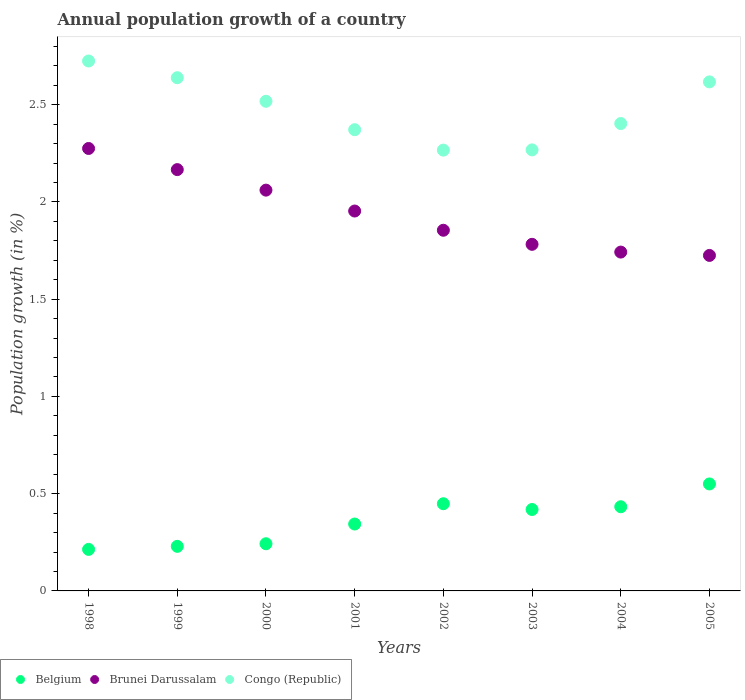What is the annual population growth in Congo (Republic) in 2002?
Ensure brevity in your answer.  2.27. Across all years, what is the maximum annual population growth in Congo (Republic)?
Ensure brevity in your answer.  2.72. Across all years, what is the minimum annual population growth in Brunei Darussalam?
Offer a terse response. 1.72. In which year was the annual population growth in Congo (Republic) minimum?
Give a very brief answer. 2002. What is the total annual population growth in Congo (Republic) in the graph?
Make the answer very short. 19.81. What is the difference between the annual population growth in Belgium in 2003 and that in 2004?
Your answer should be compact. -0.01. What is the difference between the annual population growth in Belgium in 2002 and the annual population growth in Brunei Darussalam in 2000?
Ensure brevity in your answer.  -1.61. What is the average annual population growth in Brunei Darussalam per year?
Keep it short and to the point. 1.94. In the year 1999, what is the difference between the annual population growth in Belgium and annual population growth in Congo (Republic)?
Provide a short and direct response. -2.41. In how many years, is the annual population growth in Belgium greater than 1.2 %?
Give a very brief answer. 0. What is the ratio of the annual population growth in Congo (Republic) in 2002 to that in 2004?
Your response must be concise. 0.94. Is the annual population growth in Belgium in 1998 less than that in 2003?
Offer a terse response. Yes. Is the difference between the annual population growth in Belgium in 2001 and 2004 greater than the difference between the annual population growth in Congo (Republic) in 2001 and 2004?
Provide a succinct answer. No. What is the difference between the highest and the second highest annual population growth in Congo (Republic)?
Your answer should be very brief. 0.09. What is the difference between the highest and the lowest annual population growth in Belgium?
Provide a short and direct response. 0.34. Does the annual population growth in Congo (Republic) monotonically increase over the years?
Your answer should be very brief. No. Is the annual population growth in Belgium strictly less than the annual population growth in Brunei Darussalam over the years?
Keep it short and to the point. Yes. How many dotlines are there?
Provide a succinct answer. 3. How many years are there in the graph?
Offer a terse response. 8. What is the difference between two consecutive major ticks on the Y-axis?
Provide a succinct answer. 0.5. Are the values on the major ticks of Y-axis written in scientific E-notation?
Ensure brevity in your answer.  No. Does the graph contain any zero values?
Make the answer very short. No. How are the legend labels stacked?
Give a very brief answer. Horizontal. What is the title of the graph?
Your response must be concise. Annual population growth of a country. What is the label or title of the Y-axis?
Make the answer very short. Population growth (in %). What is the Population growth (in %) of Belgium in 1998?
Your answer should be very brief. 0.21. What is the Population growth (in %) of Brunei Darussalam in 1998?
Give a very brief answer. 2.27. What is the Population growth (in %) in Congo (Republic) in 1998?
Your answer should be very brief. 2.72. What is the Population growth (in %) of Belgium in 1999?
Your answer should be very brief. 0.23. What is the Population growth (in %) of Brunei Darussalam in 1999?
Give a very brief answer. 2.17. What is the Population growth (in %) of Congo (Republic) in 1999?
Offer a very short reply. 2.64. What is the Population growth (in %) in Belgium in 2000?
Give a very brief answer. 0.24. What is the Population growth (in %) of Brunei Darussalam in 2000?
Make the answer very short. 2.06. What is the Population growth (in %) in Congo (Republic) in 2000?
Give a very brief answer. 2.52. What is the Population growth (in %) in Belgium in 2001?
Your response must be concise. 0.34. What is the Population growth (in %) of Brunei Darussalam in 2001?
Ensure brevity in your answer.  1.95. What is the Population growth (in %) in Congo (Republic) in 2001?
Provide a succinct answer. 2.37. What is the Population growth (in %) in Belgium in 2002?
Offer a very short reply. 0.45. What is the Population growth (in %) in Brunei Darussalam in 2002?
Offer a very short reply. 1.85. What is the Population growth (in %) in Congo (Republic) in 2002?
Offer a terse response. 2.27. What is the Population growth (in %) of Belgium in 2003?
Your answer should be compact. 0.42. What is the Population growth (in %) of Brunei Darussalam in 2003?
Ensure brevity in your answer.  1.78. What is the Population growth (in %) in Congo (Republic) in 2003?
Offer a very short reply. 2.27. What is the Population growth (in %) in Belgium in 2004?
Make the answer very short. 0.43. What is the Population growth (in %) in Brunei Darussalam in 2004?
Offer a terse response. 1.74. What is the Population growth (in %) in Congo (Republic) in 2004?
Provide a succinct answer. 2.4. What is the Population growth (in %) of Belgium in 2005?
Your response must be concise. 0.55. What is the Population growth (in %) in Brunei Darussalam in 2005?
Your answer should be compact. 1.72. What is the Population growth (in %) in Congo (Republic) in 2005?
Your response must be concise. 2.62. Across all years, what is the maximum Population growth (in %) in Belgium?
Keep it short and to the point. 0.55. Across all years, what is the maximum Population growth (in %) in Brunei Darussalam?
Keep it short and to the point. 2.27. Across all years, what is the maximum Population growth (in %) of Congo (Republic)?
Offer a terse response. 2.72. Across all years, what is the minimum Population growth (in %) in Belgium?
Offer a very short reply. 0.21. Across all years, what is the minimum Population growth (in %) in Brunei Darussalam?
Your response must be concise. 1.72. Across all years, what is the minimum Population growth (in %) in Congo (Republic)?
Provide a short and direct response. 2.27. What is the total Population growth (in %) of Belgium in the graph?
Provide a succinct answer. 2.88. What is the total Population growth (in %) in Brunei Darussalam in the graph?
Ensure brevity in your answer.  15.56. What is the total Population growth (in %) of Congo (Republic) in the graph?
Ensure brevity in your answer.  19.81. What is the difference between the Population growth (in %) of Belgium in 1998 and that in 1999?
Keep it short and to the point. -0.02. What is the difference between the Population growth (in %) of Brunei Darussalam in 1998 and that in 1999?
Ensure brevity in your answer.  0.11. What is the difference between the Population growth (in %) in Congo (Republic) in 1998 and that in 1999?
Provide a short and direct response. 0.09. What is the difference between the Population growth (in %) in Belgium in 1998 and that in 2000?
Your answer should be compact. -0.03. What is the difference between the Population growth (in %) in Brunei Darussalam in 1998 and that in 2000?
Make the answer very short. 0.21. What is the difference between the Population growth (in %) of Congo (Republic) in 1998 and that in 2000?
Give a very brief answer. 0.21. What is the difference between the Population growth (in %) in Belgium in 1998 and that in 2001?
Give a very brief answer. -0.13. What is the difference between the Population growth (in %) of Brunei Darussalam in 1998 and that in 2001?
Provide a short and direct response. 0.32. What is the difference between the Population growth (in %) in Congo (Republic) in 1998 and that in 2001?
Make the answer very short. 0.35. What is the difference between the Population growth (in %) in Belgium in 1998 and that in 2002?
Offer a terse response. -0.23. What is the difference between the Population growth (in %) in Brunei Darussalam in 1998 and that in 2002?
Your answer should be very brief. 0.42. What is the difference between the Population growth (in %) in Congo (Republic) in 1998 and that in 2002?
Offer a very short reply. 0.46. What is the difference between the Population growth (in %) in Belgium in 1998 and that in 2003?
Provide a succinct answer. -0.21. What is the difference between the Population growth (in %) in Brunei Darussalam in 1998 and that in 2003?
Ensure brevity in your answer.  0.49. What is the difference between the Population growth (in %) in Congo (Republic) in 1998 and that in 2003?
Offer a terse response. 0.46. What is the difference between the Population growth (in %) of Belgium in 1998 and that in 2004?
Your answer should be compact. -0.22. What is the difference between the Population growth (in %) of Brunei Darussalam in 1998 and that in 2004?
Your answer should be compact. 0.53. What is the difference between the Population growth (in %) of Congo (Republic) in 1998 and that in 2004?
Your response must be concise. 0.32. What is the difference between the Population growth (in %) in Belgium in 1998 and that in 2005?
Your answer should be very brief. -0.34. What is the difference between the Population growth (in %) of Brunei Darussalam in 1998 and that in 2005?
Give a very brief answer. 0.55. What is the difference between the Population growth (in %) in Congo (Republic) in 1998 and that in 2005?
Provide a succinct answer. 0.11. What is the difference between the Population growth (in %) of Belgium in 1999 and that in 2000?
Offer a very short reply. -0.01. What is the difference between the Population growth (in %) in Brunei Darussalam in 1999 and that in 2000?
Offer a very short reply. 0.11. What is the difference between the Population growth (in %) in Congo (Republic) in 1999 and that in 2000?
Your response must be concise. 0.12. What is the difference between the Population growth (in %) of Belgium in 1999 and that in 2001?
Offer a terse response. -0.11. What is the difference between the Population growth (in %) in Brunei Darussalam in 1999 and that in 2001?
Provide a succinct answer. 0.21. What is the difference between the Population growth (in %) in Congo (Republic) in 1999 and that in 2001?
Provide a short and direct response. 0.27. What is the difference between the Population growth (in %) in Belgium in 1999 and that in 2002?
Provide a short and direct response. -0.22. What is the difference between the Population growth (in %) in Brunei Darussalam in 1999 and that in 2002?
Your answer should be compact. 0.31. What is the difference between the Population growth (in %) in Congo (Republic) in 1999 and that in 2002?
Your answer should be compact. 0.37. What is the difference between the Population growth (in %) in Belgium in 1999 and that in 2003?
Your response must be concise. -0.19. What is the difference between the Population growth (in %) in Brunei Darussalam in 1999 and that in 2003?
Offer a very short reply. 0.38. What is the difference between the Population growth (in %) of Congo (Republic) in 1999 and that in 2003?
Give a very brief answer. 0.37. What is the difference between the Population growth (in %) in Belgium in 1999 and that in 2004?
Ensure brevity in your answer.  -0.2. What is the difference between the Population growth (in %) in Brunei Darussalam in 1999 and that in 2004?
Make the answer very short. 0.42. What is the difference between the Population growth (in %) in Congo (Republic) in 1999 and that in 2004?
Offer a very short reply. 0.24. What is the difference between the Population growth (in %) of Belgium in 1999 and that in 2005?
Provide a succinct answer. -0.32. What is the difference between the Population growth (in %) in Brunei Darussalam in 1999 and that in 2005?
Ensure brevity in your answer.  0.44. What is the difference between the Population growth (in %) in Congo (Republic) in 1999 and that in 2005?
Provide a succinct answer. 0.02. What is the difference between the Population growth (in %) in Belgium in 2000 and that in 2001?
Provide a short and direct response. -0.1. What is the difference between the Population growth (in %) of Brunei Darussalam in 2000 and that in 2001?
Your answer should be very brief. 0.11. What is the difference between the Population growth (in %) of Congo (Republic) in 2000 and that in 2001?
Ensure brevity in your answer.  0.15. What is the difference between the Population growth (in %) of Belgium in 2000 and that in 2002?
Offer a terse response. -0.21. What is the difference between the Population growth (in %) in Brunei Darussalam in 2000 and that in 2002?
Provide a succinct answer. 0.21. What is the difference between the Population growth (in %) of Congo (Republic) in 2000 and that in 2002?
Offer a terse response. 0.25. What is the difference between the Population growth (in %) in Belgium in 2000 and that in 2003?
Offer a terse response. -0.18. What is the difference between the Population growth (in %) in Brunei Darussalam in 2000 and that in 2003?
Make the answer very short. 0.28. What is the difference between the Population growth (in %) in Congo (Republic) in 2000 and that in 2003?
Offer a terse response. 0.25. What is the difference between the Population growth (in %) in Belgium in 2000 and that in 2004?
Offer a very short reply. -0.19. What is the difference between the Population growth (in %) in Brunei Darussalam in 2000 and that in 2004?
Ensure brevity in your answer.  0.32. What is the difference between the Population growth (in %) of Congo (Republic) in 2000 and that in 2004?
Your answer should be very brief. 0.11. What is the difference between the Population growth (in %) in Belgium in 2000 and that in 2005?
Ensure brevity in your answer.  -0.31. What is the difference between the Population growth (in %) of Brunei Darussalam in 2000 and that in 2005?
Keep it short and to the point. 0.34. What is the difference between the Population growth (in %) of Congo (Republic) in 2000 and that in 2005?
Your answer should be very brief. -0.1. What is the difference between the Population growth (in %) of Belgium in 2001 and that in 2002?
Offer a terse response. -0.1. What is the difference between the Population growth (in %) in Brunei Darussalam in 2001 and that in 2002?
Make the answer very short. 0.1. What is the difference between the Population growth (in %) in Congo (Republic) in 2001 and that in 2002?
Provide a succinct answer. 0.1. What is the difference between the Population growth (in %) of Belgium in 2001 and that in 2003?
Your answer should be very brief. -0.07. What is the difference between the Population growth (in %) in Brunei Darussalam in 2001 and that in 2003?
Provide a succinct answer. 0.17. What is the difference between the Population growth (in %) of Congo (Republic) in 2001 and that in 2003?
Give a very brief answer. 0.1. What is the difference between the Population growth (in %) in Belgium in 2001 and that in 2004?
Give a very brief answer. -0.09. What is the difference between the Population growth (in %) in Brunei Darussalam in 2001 and that in 2004?
Provide a succinct answer. 0.21. What is the difference between the Population growth (in %) in Congo (Republic) in 2001 and that in 2004?
Ensure brevity in your answer.  -0.03. What is the difference between the Population growth (in %) of Belgium in 2001 and that in 2005?
Your answer should be very brief. -0.21. What is the difference between the Population growth (in %) in Brunei Darussalam in 2001 and that in 2005?
Your response must be concise. 0.23. What is the difference between the Population growth (in %) of Congo (Republic) in 2001 and that in 2005?
Provide a succinct answer. -0.25. What is the difference between the Population growth (in %) in Belgium in 2002 and that in 2003?
Give a very brief answer. 0.03. What is the difference between the Population growth (in %) in Brunei Darussalam in 2002 and that in 2003?
Ensure brevity in your answer.  0.07. What is the difference between the Population growth (in %) of Congo (Republic) in 2002 and that in 2003?
Offer a terse response. -0. What is the difference between the Population growth (in %) in Belgium in 2002 and that in 2004?
Your answer should be very brief. 0.02. What is the difference between the Population growth (in %) of Brunei Darussalam in 2002 and that in 2004?
Make the answer very short. 0.11. What is the difference between the Population growth (in %) in Congo (Republic) in 2002 and that in 2004?
Offer a terse response. -0.14. What is the difference between the Population growth (in %) in Belgium in 2002 and that in 2005?
Offer a very short reply. -0.1. What is the difference between the Population growth (in %) in Brunei Darussalam in 2002 and that in 2005?
Your answer should be compact. 0.13. What is the difference between the Population growth (in %) in Congo (Republic) in 2002 and that in 2005?
Your answer should be very brief. -0.35. What is the difference between the Population growth (in %) in Belgium in 2003 and that in 2004?
Your answer should be very brief. -0.01. What is the difference between the Population growth (in %) of Brunei Darussalam in 2003 and that in 2004?
Provide a short and direct response. 0.04. What is the difference between the Population growth (in %) in Congo (Republic) in 2003 and that in 2004?
Keep it short and to the point. -0.14. What is the difference between the Population growth (in %) in Belgium in 2003 and that in 2005?
Your response must be concise. -0.13. What is the difference between the Population growth (in %) of Brunei Darussalam in 2003 and that in 2005?
Your answer should be compact. 0.06. What is the difference between the Population growth (in %) of Congo (Republic) in 2003 and that in 2005?
Your answer should be very brief. -0.35. What is the difference between the Population growth (in %) of Belgium in 2004 and that in 2005?
Make the answer very short. -0.12. What is the difference between the Population growth (in %) in Brunei Darussalam in 2004 and that in 2005?
Ensure brevity in your answer.  0.02. What is the difference between the Population growth (in %) in Congo (Republic) in 2004 and that in 2005?
Give a very brief answer. -0.21. What is the difference between the Population growth (in %) of Belgium in 1998 and the Population growth (in %) of Brunei Darussalam in 1999?
Your answer should be compact. -1.95. What is the difference between the Population growth (in %) in Belgium in 1998 and the Population growth (in %) in Congo (Republic) in 1999?
Give a very brief answer. -2.43. What is the difference between the Population growth (in %) in Brunei Darussalam in 1998 and the Population growth (in %) in Congo (Republic) in 1999?
Provide a short and direct response. -0.36. What is the difference between the Population growth (in %) of Belgium in 1998 and the Population growth (in %) of Brunei Darussalam in 2000?
Ensure brevity in your answer.  -1.85. What is the difference between the Population growth (in %) of Belgium in 1998 and the Population growth (in %) of Congo (Republic) in 2000?
Your answer should be compact. -2.3. What is the difference between the Population growth (in %) in Brunei Darussalam in 1998 and the Population growth (in %) in Congo (Republic) in 2000?
Offer a very short reply. -0.24. What is the difference between the Population growth (in %) of Belgium in 1998 and the Population growth (in %) of Brunei Darussalam in 2001?
Your response must be concise. -1.74. What is the difference between the Population growth (in %) in Belgium in 1998 and the Population growth (in %) in Congo (Republic) in 2001?
Give a very brief answer. -2.16. What is the difference between the Population growth (in %) of Brunei Darussalam in 1998 and the Population growth (in %) of Congo (Republic) in 2001?
Your response must be concise. -0.1. What is the difference between the Population growth (in %) of Belgium in 1998 and the Population growth (in %) of Brunei Darussalam in 2002?
Your answer should be very brief. -1.64. What is the difference between the Population growth (in %) in Belgium in 1998 and the Population growth (in %) in Congo (Republic) in 2002?
Ensure brevity in your answer.  -2.05. What is the difference between the Population growth (in %) of Brunei Darussalam in 1998 and the Population growth (in %) of Congo (Republic) in 2002?
Ensure brevity in your answer.  0.01. What is the difference between the Population growth (in %) in Belgium in 1998 and the Population growth (in %) in Brunei Darussalam in 2003?
Ensure brevity in your answer.  -1.57. What is the difference between the Population growth (in %) of Belgium in 1998 and the Population growth (in %) of Congo (Republic) in 2003?
Make the answer very short. -2.05. What is the difference between the Population growth (in %) of Brunei Darussalam in 1998 and the Population growth (in %) of Congo (Republic) in 2003?
Provide a short and direct response. 0.01. What is the difference between the Population growth (in %) in Belgium in 1998 and the Population growth (in %) in Brunei Darussalam in 2004?
Keep it short and to the point. -1.53. What is the difference between the Population growth (in %) of Belgium in 1998 and the Population growth (in %) of Congo (Republic) in 2004?
Ensure brevity in your answer.  -2.19. What is the difference between the Population growth (in %) of Brunei Darussalam in 1998 and the Population growth (in %) of Congo (Republic) in 2004?
Provide a short and direct response. -0.13. What is the difference between the Population growth (in %) in Belgium in 1998 and the Population growth (in %) in Brunei Darussalam in 2005?
Offer a very short reply. -1.51. What is the difference between the Population growth (in %) of Belgium in 1998 and the Population growth (in %) of Congo (Republic) in 2005?
Your answer should be compact. -2.4. What is the difference between the Population growth (in %) of Brunei Darussalam in 1998 and the Population growth (in %) of Congo (Republic) in 2005?
Make the answer very short. -0.34. What is the difference between the Population growth (in %) in Belgium in 1999 and the Population growth (in %) in Brunei Darussalam in 2000?
Your response must be concise. -1.83. What is the difference between the Population growth (in %) in Belgium in 1999 and the Population growth (in %) in Congo (Republic) in 2000?
Ensure brevity in your answer.  -2.29. What is the difference between the Population growth (in %) of Brunei Darussalam in 1999 and the Population growth (in %) of Congo (Republic) in 2000?
Give a very brief answer. -0.35. What is the difference between the Population growth (in %) of Belgium in 1999 and the Population growth (in %) of Brunei Darussalam in 2001?
Ensure brevity in your answer.  -1.72. What is the difference between the Population growth (in %) of Belgium in 1999 and the Population growth (in %) of Congo (Republic) in 2001?
Your response must be concise. -2.14. What is the difference between the Population growth (in %) in Brunei Darussalam in 1999 and the Population growth (in %) in Congo (Republic) in 2001?
Ensure brevity in your answer.  -0.21. What is the difference between the Population growth (in %) in Belgium in 1999 and the Population growth (in %) in Brunei Darussalam in 2002?
Offer a very short reply. -1.63. What is the difference between the Population growth (in %) in Belgium in 1999 and the Population growth (in %) in Congo (Republic) in 2002?
Offer a very short reply. -2.04. What is the difference between the Population growth (in %) in Brunei Darussalam in 1999 and the Population growth (in %) in Congo (Republic) in 2002?
Ensure brevity in your answer.  -0.1. What is the difference between the Population growth (in %) of Belgium in 1999 and the Population growth (in %) of Brunei Darussalam in 2003?
Offer a very short reply. -1.55. What is the difference between the Population growth (in %) of Belgium in 1999 and the Population growth (in %) of Congo (Republic) in 2003?
Your response must be concise. -2.04. What is the difference between the Population growth (in %) in Brunei Darussalam in 1999 and the Population growth (in %) in Congo (Republic) in 2003?
Offer a very short reply. -0.1. What is the difference between the Population growth (in %) of Belgium in 1999 and the Population growth (in %) of Brunei Darussalam in 2004?
Your answer should be compact. -1.51. What is the difference between the Population growth (in %) of Belgium in 1999 and the Population growth (in %) of Congo (Republic) in 2004?
Your answer should be compact. -2.17. What is the difference between the Population growth (in %) of Brunei Darussalam in 1999 and the Population growth (in %) of Congo (Republic) in 2004?
Make the answer very short. -0.24. What is the difference between the Population growth (in %) of Belgium in 1999 and the Population growth (in %) of Brunei Darussalam in 2005?
Give a very brief answer. -1.5. What is the difference between the Population growth (in %) of Belgium in 1999 and the Population growth (in %) of Congo (Republic) in 2005?
Your answer should be very brief. -2.39. What is the difference between the Population growth (in %) of Brunei Darussalam in 1999 and the Population growth (in %) of Congo (Republic) in 2005?
Make the answer very short. -0.45. What is the difference between the Population growth (in %) in Belgium in 2000 and the Population growth (in %) in Brunei Darussalam in 2001?
Offer a terse response. -1.71. What is the difference between the Population growth (in %) in Belgium in 2000 and the Population growth (in %) in Congo (Republic) in 2001?
Keep it short and to the point. -2.13. What is the difference between the Population growth (in %) of Brunei Darussalam in 2000 and the Population growth (in %) of Congo (Republic) in 2001?
Provide a short and direct response. -0.31. What is the difference between the Population growth (in %) in Belgium in 2000 and the Population growth (in %) in Brunei Darussalam in 2002?
Provide a succinct answer. -1.61. What is the difference between the Population growth (in %) of Belgium in 2000 and the Population growth (in %) of Congo (Republic) in 2002?
Your response must be concise. -2.02. What is the difference between the Population growth (in %) in Brunei Darussalam in 2000 and the Population growth (in %) in Congo (Republic) in 2002?
Your answer should be very brief. -0.21. What is the difference between the Population growth (in %) in Belgium in 2000 and the Population growth (in %) in Brunei Darussalam in 2003?
Keep it short and to the point. -1.54. What is the difference between the Population growth (in %) in Belgium in 2000 and the Population growth (in %) in Congo (Republic) in 2003?
Offer a terse response. -2.03. What is the difference between the Population growth (in %) of Brunei Darussalam in 2000 and the Population growth (in %) of Congo (Republic) in 2003?
Make the answer very short. -0.21. What is the difference between the Population growth (in %) of Belgium in 2000 and the Population growth (in %) of Brunei Darussalam in 2004?
Your answer should be very brief. -1.5. What is the difference between the Population growth (in %) in Belgium in 2000 and the Population growth (in %) in Congo (Republic) in 2004?
Your answer should be very brief. -2.16. What is the difference between the Population growth (in %) in Brunei Darussalam in 2000 and the Population growth (in %) in Congo (Republic) in 2004?
Provide a succinct answer. -0.34. What is the difference between the Population growth (in %) in Belgium in 2000 and the Population growth (in %) in Brunei Darussalam in 2005?
Offer a terse response. -1.48. What is the difference between the Population growth (in %) of Belgium in 2000 and the Population growth (in %) of Congo (Republic) in 2005?
Your answer should be very brief. -2.37. What is the difference between the Population growth (in %) in Brunei Darussalam in 2000 and the Population growth (in %) in Congo (Republic) in 2005?
Your answer should be compact. -0.56. What is the difference between the Population growth (in %) of Belgium in 2001 and the Population growth (in %) of Brunei Darussalam in 2002?
Your answer should be very brief. -1.51. What is the difference between the Population growth (in %) in Belgium in 2001 and the Population growth (in %) in Congo (Republic) in 2002?
Your answer should be compact. -1.92. What is the difference between the Population growth (in %) in Brunei Darussalam in 2001 and the Population growth (in %) in Congo (Republic) in 2002?
Keep it short and to the point. -0.31. What is the difference between the Population growth (in %) in Belgium in 2001 and the Population growth (in %) in Brunei Darussalam in 2003?
Your answer should be compact. -1.44. What is the difference between the Population growth (in %) in Belgium in 2001 and the Population growth (in %) in Congo (Republic) in 2003?
Make the answer very short. -1.92. What is the difference between the Population growth (in %) in Brunei Darussalam in 2001 and the Population growth (in %) in Congo (Republic) in 2003?
Give a very brief answer. -0.31. What is the difference between the Population growth (in %) in Belgium in 2001 and the Population growth (in %) in Brunei Darussalam in 2004?
Provide a succinct answer. -1.4. What is the difference between the Population growth (in %) of Belgium in 2001 and the Population growth (in %) of Congo (Republic) in 2004?
Provide a succinct answer. -2.06. What is the difference between the Population growth (in %) of Brunei Darussalam in 2001 and the Population growth (in %) of Congo (Republic) in 2004?
Give a very brief answer. -0.45. What is the difference between the Population growth (in %) in Belgium in 2001 and the Population growth (in %) in Brunei Darussalam in 2005?
Ensure brevity in your answer.  -1.38. What is the difference between the Population growth (in %) in Belgium in 2001 and the Population growth (in %) in Congo (Republic) in 2005?
Keep it short and to the point. -2.27. What is the difference between the Population growth (in %) of Brunei Darussalam in 2001 and the Population growth (in %) of Congo (Republic) in 2005?
Ensure brevity in your answer.  -0.66. What is the difference between the Population growth (in %) in Belgium in 2002 and the Population growth (in %) in Brunei Darussalam in 2003?
Provide a short and direct response. -1.33. What is the difference between the Population growth (in %) of Belgium in 2002 and the Population growth (in %) of Congo (Republic) in 2003?
Give a very brief answer. -1.82. What is the difference between the Population growth (in %) in Brunei Darussalam in 2002 and the Population growth (in %) in Congo (Republic) in 2003?
Offer a terse response. -0.41. What is the difference between the Population growth (in %) of Belgium in 2002 and the Population growth (in %) of Brunei Darussalam in 2004?
Offer a terse response. -1.29. What is the difference between the Population growth (in %) in Belgium in 2002 and the Population growth (in %) in Congo (Republic) in 2004?
Provide a succinct answer. -1.95. What is the difference between the Population growth (in %) in Brunei Darussalam in 2002 and the Population growth (in %) in Congo (Republic) in 2004?
Give a very brief answer. -0.55. What is the difference between the Population growth (in %) in Belgium in 2002 and the Population growth (in %) in Brunei Darussalam in 2005?
Make the answer very short. -1.28. What is the difference between the Population growth (in %) of Belgium in 2002 and the Population growth (in %) of Congo (Republic) in 2005?
Provide a succinct answer. -2.17. What is the difference between the Population growth (in %) of Brunei Darussalam in 2002 and the Population growth (in %) of Congo (Republic) in 2005?
Make the answer very short. -0.76. What is the difference between the Population growth (in %) in Belgium in 2003 and the Population growth (in %) in Brunei Darussalam in 2004?
Ensure brevity in your answer.  -1.32. What is the difference between the Population growth (in %) of Belgium in 2003 and the Population growth (in %) of Congo (Republic) in 2004?
Your answer should be very brief. -1.98. What is the difference between the Population growth (in %) of Brunei Darussalam in 2003 and the Population growth (in %) of Congo (Republic) in 2004?
Offer a terse response. -0.62. What is the difference between the Population growth (in %) in Belgium in 2003 and the Population growth (in %) in Brunei Darussalam in 2005?
Your answer should be compact. -1.31. What is the difference between the Population growth (in %) in Belgium in 2003 and the Population growth (in %) in Congo (Republic) in 2005?
Your answer should be compact. -2.2. What is the difference between the Population growth (in %) in Brunei Darussalam in 2003 and the Population growth (in %) in Congo (Republic) in 2005?
Offer a terse response. -0.84. What is the difference between the Population growth (in %) of Belgium in 2004 and the Population growth (in %) of Brunei Darussalam in 2005?
Ensure brevity in your answer.  -1.29. What is the difference between the Population growth (in %) of Belgium in 2004 and the Population growth (in %) of Congo (Republic) in 2005?
Make the answer very short. -2.18. What is the difference between the Population growth (in %) of Brunei Darussalam in 2004 and the Population growth (in %) of Congo (Republic) in 2005?
Your response must be concise. -0.88. What is the average Population growth (in %) of Belgium per year?
Your response must be concise. 0.36. What is the average Population growth (in %) of Brunei Darussalam per year?
Keep it short and to the point. 1.94. What is the average Population growth (in %) of Congo (Republic) per year?
Offer a terse response. 2.48. In the year 1998, what is the difference between the Population growth (in %) of Belgium and Population growth (in %) of Brunei Darussalam?
Your response must be concise. -2.06. In the year 1998, what is the difference between the Population growth (in %) of Belgium and Population growth (in %) of Congo (Republic)?
Provide a short and direct response. -2.51. In the year 1998, what is the difference between the Population growth (in %) in Brunei Darussalam and Population growth (in %) in Congo (Republic)?
Give a very brief answer. -0.45. In the year 1999, what is the difference between the Population growth (in %) of Belgium and Population growth (in %) of Brunei Darussalam?
Ensure brevity in your answer.  -1.94. In the year 1999, what is the difference between the Population growth (in %) in Belgium and Population growth (in %) in Congo (Republic)?
Give a very brief answer. -2.41. In the year 1999, what is the difference between the Population growth (in %) in Brunei Darussalam and Population growth (in %) in Congo (Republic)?
Offer a terse response. -0.47. In the year 2000, what is the difference between the Population growth (in %) in Belgium and Population growth (in %) in Brunei Darussalam?
Ensure brevity in your answer.  -1.82. In the year 2000, what is the difference between the Population growth (in %) of Belgium and Population growth (in %) of Congo (Republic)?
Provide a succinct answer. -2.27. In the year 2000, what is the difference between the Population growth (in %) in Brunei Darussalam and Population growth (in %) in Congo (Republic)?
Your answer should be very brief. -0.46. In the year 2001, what is the difference between the Population growth (in %) of Belgium and Population growth (in %) of Brunei Darussalam?
Offer a terse response. -1.61. In the year 2001, what is the difference between the Population growth (in %) in Belgium and Population growth (in %) in Congo (Republic)?
Give a very brief answer. -2.03. In the year 2001, what is the difference between the Population growth (in %) of Brunei Darussalam and Population growth (in %) of Congo (Republic)?
Make the answer very short. -0.42. In the year 2002, what is the difference between the Population growth (in %) of Belgium and Population growth (in %) of Brunei Darussalam?
Ensure brevity in your answer.  -1.41. In the year 2002, what is the difference between the Population growth (in %) of Belgium and Population growth (in %) of Congo (Republic)?
Your answer should be very brief. -1.82. In the year 2002, what is the difference between the Population growth (in %) of Brunei Darussalam and Population growth (in %) of Congo (Republic)?
Make the answer very short. -0.41. In the year 2003, what is the difference between the Population growth (in %) in Belgium and Population growth (in %) in Brunei Darussalam?
Give a very brief answer. -1.36. In the year 2003, what is the difference between the Population growth (in %) in Belgium and Population growth (in %) in Congo (Republic)?
Offer a very short reply. -1.85. In the year 2003, what is the difference between the Population growth (in %) in Brunei Darussalam and Population growth (in %) in Congo (Republic)?
Your answer should be very brief. -0.49. In the year 2004, what is the difference between the Population growth (in %) in Belgium and Population growth (in %) in Brunei Darussalam?
Your answer should be compact. -1.31. In the year 2004, what is the difference between the Population growth (in %) of Belgium and Population growth (in %) of Congo (Republic)?
Provide a short and direct response. -1.97. In the year 2004, what is the difference between the Population growth (in %) in Brunei Darussalam and Population growth (in %) in Congo (Republic)?
Your response must be concise. -0.66. In the year 2005, what is the difference between the Population growth (in %) of Belgium and Population growth (in %) of Brunei Darussalam?
Provide a succinct answer. -1.17. In the year 2005, what is the difference between the Population growth (in %) of Belgium and Population growth (in %) of Congo (Republic)?
Make the answer very short. -2.07. In the year 2005, what is the difference between the Population growth (in %) of Brunei Darussalam and Population growth (in %) of Congo (Republic)?
Keep it short and to the point. -0.89. What is the ratio of the Population growth (in %) in Belgium in 1998 to that in 1999?
Ensure brevity in your answer.  0.93. What is the ratio of the Population growth (in %) in Brunei Darussalam in 1998 to that in 1999?
Give a very brief answer. 1.05. What is the ratio of the Population growth (in %) in Congo (Republic) in 1998 to that in 1999?
Your answer should be very brief. 1.03. What is the ratio of the Population growth (in %) of Belgium in 1998 to that in 2000?
Your answer should be very brief. 0.88. What is the ratio of the Population growth (in %) in Brunei Darussalam in 1998 to that in 2000?
Offer a terse response. 1.1. What is the ratio of the Population growth (in %) in Congo (Republic) in 1998 to that in 2000?
Provide a short and direct response. 1.08. What is the ratio of the Population growth (in %) of Belgium in 1998 to that in 2001?
Give a very brief answer. 0.62. What is the ratio of the Population growth (in %) in Brunei Darussalam in 1998 to that in 2001?
Give a very brief answer. 1.16. What is the ratio of the Population growth (in %) in Congo (Republic) in 1998 to that in 2001?
Your answer should be compact. 1.15. What is the ratio of the Population growth (in %) in Belgium in 1998 to that in 2002?
Provide a short and direct response. 0.48. What is the ratio of the Population growth (in %) of Brunei Darussalam in 1998 to that in 2002?
Your response must be concise. 1.23. What is the ratio of the Population growth (in %) in Congo (Republic) in 1998 to that in 2002?
Your answer should be very brief. 1.2. What is the ratio of the Population growth (in %) of Belgium in 1998 to that in 2003?
Provide a short and direct response. 0.51. What is the ratio of the Population growth (in %) in Brunei Darussalam in 1998 to that in 2003?
Offer a very short reply. 1.28. What is the ratio of the Population growth (in %) in Congo (Republic) in 1998 to that in 2003?
Ensure brevity in your answer.  1.2. What is the ratio of the Population growth (in %) in Belgium in 1998 to that in 2004?
Make the answer very short. 0.49. What is the ratio of the Population growth (in %) in Brunei Darussalam in 1998 to that in 2004?
Your answer should be very brief. 1.31. What is the ratio of the Population growth (in %) of Congo (Republic) in 1998 to that in 2004?
Provide a short and direct response. 1.13. What is the ratio of the Population growth (in %) of Belgium in 1998 to that in 2005?
Ensure brevity in your answer.  0.39. What is the ratio of the Population growth (in %) of Brunei Darussalam in 1998 to that in 2005?
Give a very brief answer. 1.32. What is the ratio of the Population growth (in %) of Congo (Republic) in 1998 to that in 2005?
Provide a succinct answer. 1.04. What is the ratio of the Population growth (in %) of Belgium in 1999 to that in 2000?
Keep it short and to the point. 0.94. What is the ratio of the Population growth (in %) of Brunei Darussalam in 1999 to that in 2000?
Your response must be concise. 1.05. What is the ratio of the Population growth (in %) in Congo (Republic) in 1999 to that in 2000?
Provide a short and direct response. 1.05. What is the ratio of the Population growth (in %) in Belgium in 1999 to that in 2001?
Keep it short and to the point. 0.67. What is the ratio of the Population growth (in %) of Brunei Darussalam in 1999 to that in 2001?
Ensure brevity in your answer.  1.11. What is the ratio of the Population growth (in %) in Congo (Republic) in 1999 to that in 2001?
Offer a very short reply. 1.11. What is the ratio of the Population growth (in %) of Belgium in 1999 to that in 2002?
Your answer should be very brief. 0.51. What is the ratio of the Population growth (in %) in Brunei Darussalam in 1999 to that in 2002?
Keep it short and to the point. 1.17. What is the ratio of the Population growth (in %) in Congo (Republic) in 1999 to that in 2002?
Make the answer very short. 1.16. What is the ratio of the Population growth (in %) of Belgium in 1999 to that in 2003?
Provide a succinct answer. 0.55. What is the ratio of the Population growth (in %) of Brunei Darussalam in 1999 to that in 2003?
Give a very brief answer. 1.22. What is the ratio of the Population growth (in %) in Congo (Republic) in 1999 to that in 2003?
Make the answer very short. 1.16. What is the ratio of the Population growth (in %) of Belgium in 1999 to that in 2004?
Provide a succinct answer. 0.53. What is the ratio of the Population growth (in %) of Brunei Darussalam in 1999 to that in 2004?
Provide a short and direct response. 1.24. What is the ratio of the Population growth (in %) of Congo (Republic) in 1999 to that in 2004?
Offer a very short reply. 1.1. What is the ratio of the Population growth (in %) of Belgium in 1999 to that in 2005?
Ensure brevity in your answer.  0.42. What is the ratio of the Population growth (in %) of Brunei Darussalam in 1999 to that in 2005?
Ensure brevity in your answer.  1.26. What is the ratio of the Population growth (in %) in Congo (Republic) in 1999 to that in 2005?
Provide a succinct answer. 1.01. What is the ratio of the Population growth (in %) of Belgium in 2000 to that in 2001?
Ensure brevity in your answer.  0.71. What is the ratio of the Population growth (in %) in Brunei Darussalam in 2000 to that in 2001?
Your answer should be compact. 1.05. What is the ratio of the Population growth (in %) in Congo (Republic) in 2000 to that in 2001?
Provide a succinct answer. 1.06. What is the ratio of the Population growth (in %) in Belgium in 2000 to that in 2002?
Offer a very short reply. 0.54. What is the ratio of the Population growth (in %) of Brunei Darussalam in 2000 to that in 2002?
Your response must be concise. 1.11. What is the ratio of the Population growth (in %) of Congo (Republic) in 2000 to that in 2002?
Make the answer very short. 1.11. What is the ratio of the Population growth (in %) in Belgium in 2000 to that in 2003?
Keep it short and to the point. 0.58. What is the ratio of the Population growth (in %) of Brunei Darussalam in 2000 to that in 2003?
Offer a terse response. 1.16. What is the ratio of the Population growth (in %) in Congo (Republic) in 2000 to that in 2003?
Provide a short and direct response. 1.11. What is the ratio of the Population growth (in %) in Belgium in 2000 to that in 2004?
Your answer should be compact. 0.56. What is the ratio of the Population growth (in %) of Brunei Darussalam in 2000 to that in 2004?
Give a very brief answer. 1.18. What is the ratio of the Population growth (in %) in Congo (Republic) in 2000 to that in 2004?
Give a very brief answer. 1.05. What is the ratio of the Population growth (in %) of Belgium in 2000 to that in 2005?
Provide a short and direct response. 0.44. What is the ratio of the Population growth (in %) in Brunei Darussalam in 2000 to that in 2005?
Give a very brief answer. 1.19. What is the ratio of the Population growth (in %) in Congo (Republic) in 2000 to that in 2005?
Give a very brief answer. 0.96. What is the ratio of the Population growth (in %) of Belgium in 2001 to that in 2002?
Ensure brevity in your answer.  0.77. What is the ratio of the Population growth (in %) in Brunei Darussalam in 2001 to that in 2002?
Give a very brief answer. 1.05. What is the ratio of the Population growth (in %) of Congo (Republic) in 2001 to that in 2002?
Your response must be concise. 1.05. What is the ratio of the Population growth (in %) of Belgium in 2001 to that in 2003?
Give a very brief answer. 0.82. What is the ratio of the Population growth (in %) in Brunei Darussalam in 2001 to that in 2003?
Provide a short and direct response. 1.1. What is the ratio of the Population growth (in %) in Congo (Republic) in 2001 to that in 2003?
Your response must be concise. 1.05. What is the ratio of the Population growth (in %) in Belgium in 2001 to that in 2004?
Offer a very short reply. 0.79. What is the ratio of the Population growth (in %) in Brunei Darussalam in 2001 to that in 2004?
Ensure brevity in your answer.  1.12. What is the ratio of the Population growth (in %) of Belgium in 2001 to that in 2005?
Your response must be concise. 0.63. What is the ratio of the Population growth (in %) of Brunei Darussalam in 2001 to that in 2005?
Your answer should be very brief. 1.13. What is the ratio of the Population growth (in %) in Congo (Republic) in 2001 to that in 2005?
Your answer should be very brief. 0.91. What is the ratio of the Population growth (in %) of Belgium in 2002 to that in 2003?
Provide a short and direct response. 1.07. What is the ratio of the Population growth (in %) in Brunei Darussalam in 2002 to that in 2003?
Provide a short and direct response. 1.04. What is the ratio of the Population growth (in %) in Congo (Republic) in 2002 to that in 2003?
Your response must be concise. 1. What is the ratio of the Population growth (in %) in Belgium in 2002 to that in 2004?
Provide a short and direct response. 1.04. What is the ratio of the Population growth (in %) in Brunei Darussalam in 2002 to that in 2004?
Keep it short and to the point. 1.06. What is the ratio of the Population growth (in %) of Congo (Republic) in 2002 to that in 2004?
Give a very brief answer. 0.94. What is the ratio of the Population growth (in %) of Belgium in 2002 to that in 2005?
Ensure brevity in your answer.  0.81. What is the ratio of the Population growth (in %) of Brunei Darussalam in 2002 to that in 2005?
Your answer should be compact. 1.07. What is the ratio of the Population growth (in %) in Congo (Republic) in 2002 to that in 2005?
Give a very brief answer. 0.87. What is the ratio of the Population growth (in %) in Belgium in 2003 to that in 2004?
Give a very brief answer. 0.97. What is the ratio of the Population growth (in %) of Brunei Darussalam in 2003 to that in 2004?
Give a very brief answer. 1.02. What is the ratio of the Population growth (in %) in Congo (Republic) in 2003 to that in 2004?
Keep it short and to the point. 0.94. What is the ratio of the Population growth (in %) of Belgium in 2003 to that in 2005?
Your answer should be very brief. 0.76. What is the ratio of the Population growth (in %) of Brunei Darussalam in 2003 to that in 2005?
Offer a terse response. 1.03. What is the ratio of the Population growth (in %) of Congo (Republic) in 2003 to that in 2005?
Keep it short and to the point. 0.87. What is the ratio of the Population growth (in %) in Belgium in 2004 to that in 2005?
Your answer should be compact. 0.79. What is the ratio of the Population growth (in %) of Brunei Darussalam in 2004 to that in 2005?
Keep it short and to the point. 1.01. What is the ratio of the Population growth (in %) in Congo (Republic) in 2004 to that in 2005?
Provide a short and direct response. 0.92. What is the difference between the highest and the second highest Population growth (in %) in Belgium?
Provide a succinct answer. 0.1. What is the difference between the highest and the second highest Population growth (in %) of Brunei Darussalam?
Your answer should be compact. 0.11. What is the difference between the highest and the second highest Population growth (in %) in Congo (Republic)?
Keep it short and to the point. 0.09. What is the difference between the highest and the lowest Population growth (in %) of Belgium?
Offer a terse response. 0.34. What is the difference between the highest and the lowest Population growth (in %) in Brunei Darussalam?
Offer a very short reply. 0.55. What is the difference between the highest and the lowest Population growth (in %) in Congo (Republic)?
Keep it short and to the point. 0.46. 